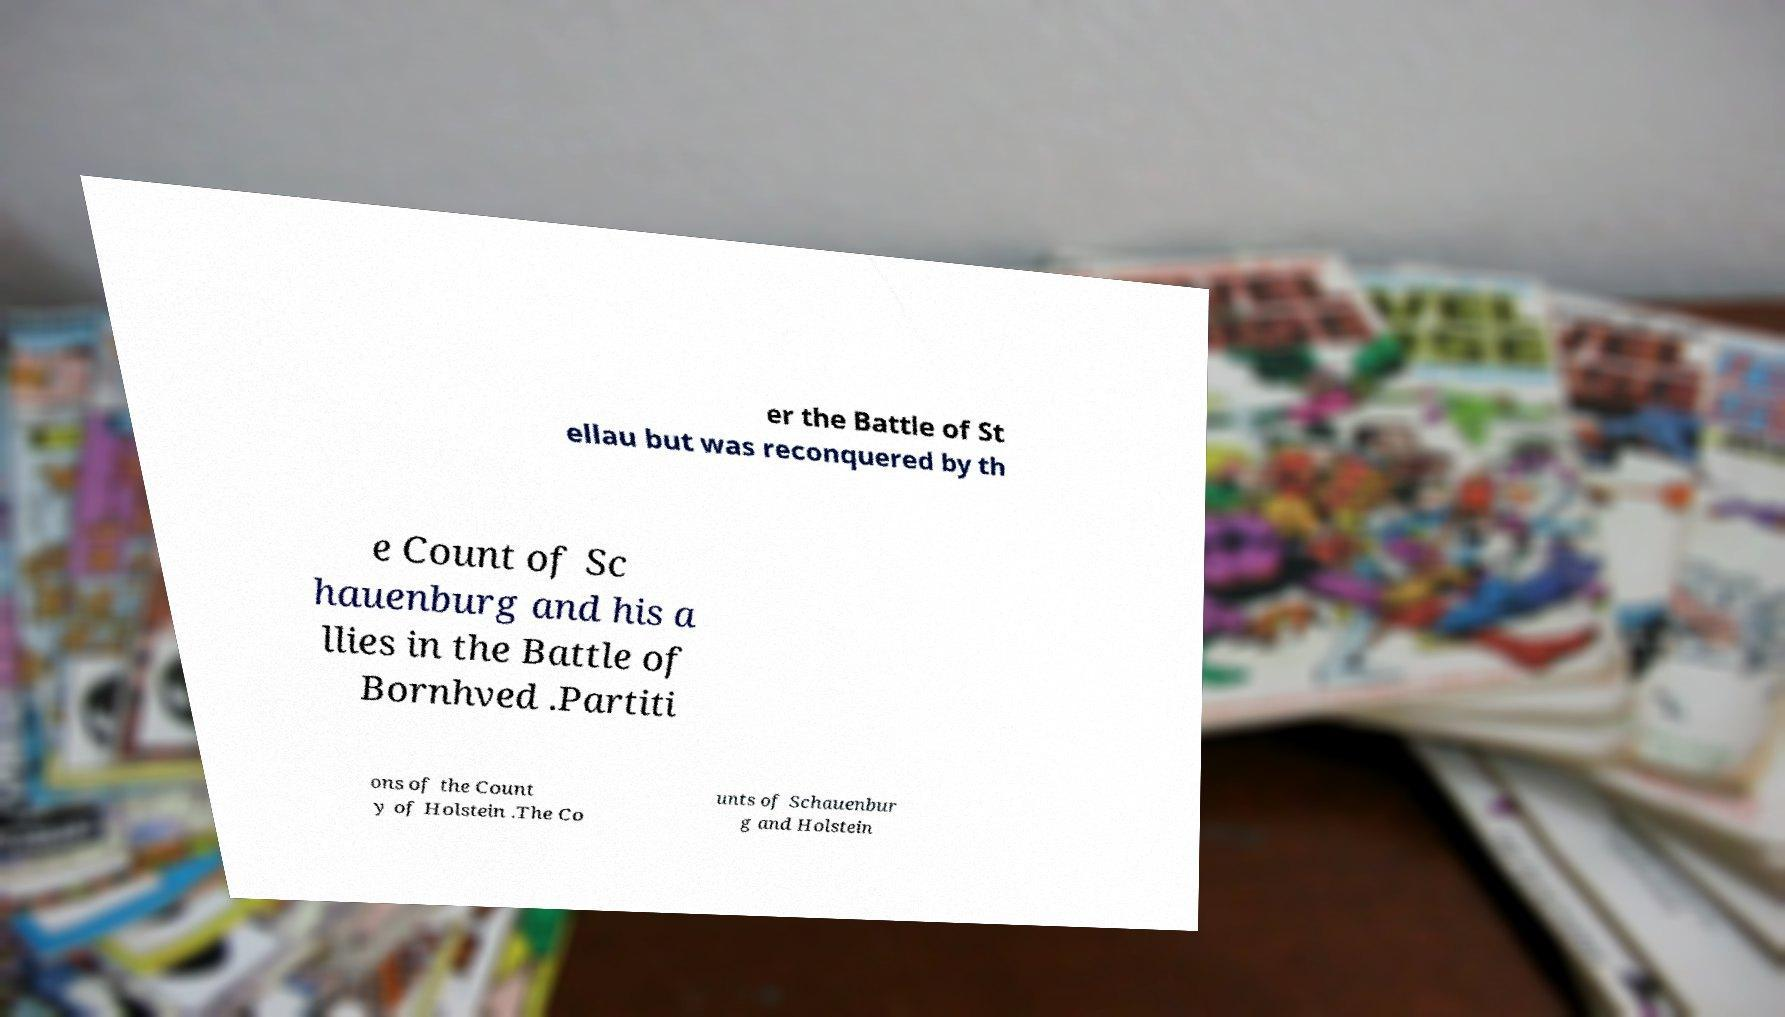Please read and relay the text visible in this image. What does it say? er the Battle of St ellau but was reconquered by th e Count of Sc hauenburg and his a llies in the Battle of Bornhved .Partiti ons of the Count y of Holstein .The Co unts of Schauenbur g and Holstein 